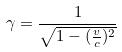Convert formula to latex. <formula><loc_0><loc_0><loc_500><loc_500>\gamma = \frac { 1 } { \sqrt { 1 - ( \frac { v } { c } ) ^ { 2 } } }</formula> 